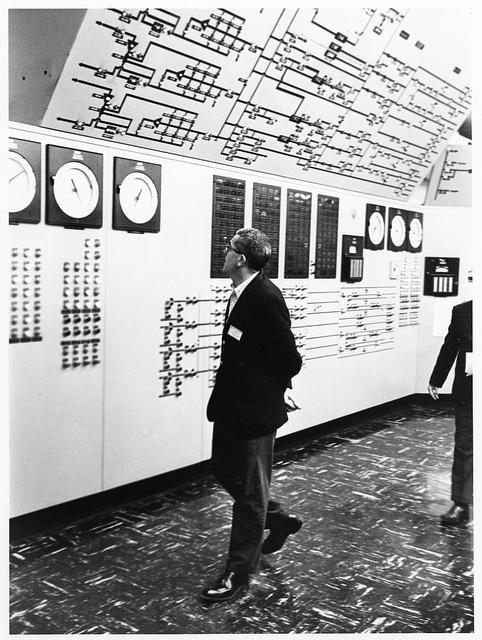How many colors are in this photo?
Give a very brief answer. 2. How many people can you see?
Give a very brief answer. 2. How many clocks are there?
Give a very brief answer. 2. 